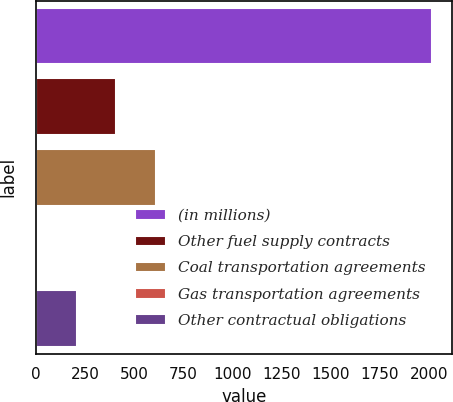Convert chart to OTSL. <chart><loc_0><loc_0><loc_500><loc_500><bar_chart><fcel>(in millions)<fcel>Other fuel supply contracts<fcel>Coal transportation agreements<fcel>Gas transportation agreements<fcel>Other contractual obligations<nl><fcel>2014<fcel>408.4<fcel>609.1<fcel>7<fcel>207.7<nl></chart> 